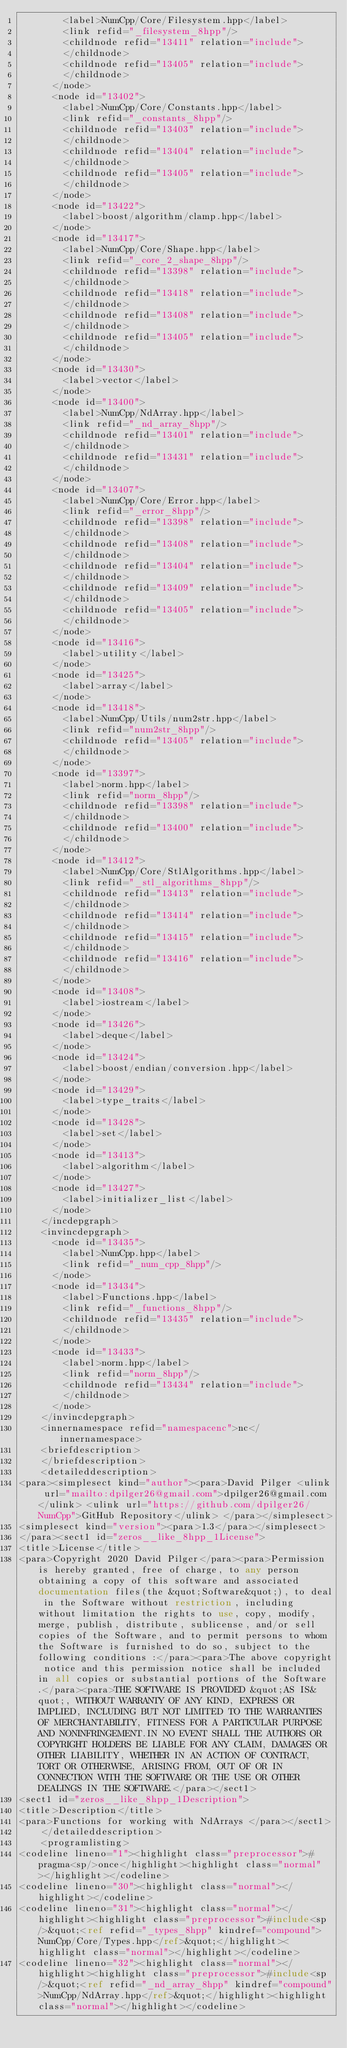<code> <loc_0><loc_0><loc_500><loc_500><_XML_>        <label>NumCpp/Core/Filesystem.hpp</label>
        <link refid="_filesystem_8hpp"/>
        <childnode refid="13411" relation="include">
        </childnode>
        <childnode refid="13405" relation="include">
        </childnode>
      </node>
      <node id="13402">
        <label>NumCpp/Core/Constants.hpp</label>
        <link refid="_constants_8hpp"/>
        <childnode refid="13403" relation="include">
        </childnode>
        <childnode refid="13404" relation="include">
        </childnode>
        <childnode refid="13405" relation="include">
        </childnode>
      </node>
      <node id="13422">
        <label>boost/algorithm/clamp.hpp</label>
      </node>
      <node id="13417">
        <label>NumCpp/Core/Shape.hpp</label>
        <link refid="_core_2_shape_8hpp"/>
        <childnode refid="13398" relation="include">
        </childnode>
        <childnode refid="13418" relation="include">
        </childnode>
        <childnode refid="13408" relation="include">
        </childnode>
        <childnode refid="13405" relation="include">
        </childnode>
      </node>
      <node id="13430">
        <label>vector</label>
      </node>
      <node id="13400">
        <label>NumCpp/NdArray.hpp</label>
        <link refid="_nd_array_8hpp"/>
        <childnode refid="13401" relation="include">
        </childnode>
        <childnode refid="13431" relation="include">
        </childnode>
      </node>
      <node id="13407">
        <label>NumCpp/Core/Error.hpp</label>
        <link refid="_error_8hpp"/>
        <childnode refid="13398" relation="include">
        </childnode>
        <childnode refid="13408" relation="include">
        </childnode>
        <childnode refid="13404" relation="include">
        </childnode>
        <childnode refid="13409" relation="include">
        </childnode>
        <childnode refid="13405" relation="include">
        </childnode>
      </node>
      <node id="13416">
        <label>utility</label>
      </node>
      <node id="13425">
        <label>array</label>
      </node>
      <node id="13418">
        <label>NumCpp/Utils/num2str.hpp</label>
        <link refid="num2str_8hpp"/>
        <childnode refid="13405" relation="include">
        </childnode>
      </node>
      <node id="13397">
        <label>norm.hpp</label>
        <link refid="norm_8hpp"/>
        <childnode refid="13398" relation="include">
        </childnode>
        <childnode refid="13400" relation="include">
        </childnode>
      </node>
      <node id="13412">
        <label>NumCpp/Core/StlAlgorithms.hpp</label>
        <link refid="_stl_algorithms_8hpp"/>
        <childnode refid="13413" relation="include">
        </childnode>
        <childnode refid="13414" relation="include">
        </childnode>
        <childnode refid="13415" relation="include">
        </childnode>
        <childnode refid="13416" relation="include">
        </childnode>
      </node>
      <node id="13408">
        <label>iostream</label>
      </node>
      <node id="13426">
        <label>deque</label>
      </node>
      <node id="13424">
        <label>boost/endian/conversion.hpp</label>
      </node>
      <node id="13429">
        <label>type_traits</label>
      </node>
      <node id="13428">
        <label>set</label>
      </node>
      <node id="13413">
        <label>algorithm</label>
      </node>
      <node id="13427">
        <label>initializer_list</label>
      </node>
    </incdepgraph>
    <invincdepgraph>
      <node id="13435">
        <label>NumCpp.hpp</label>
        <link refid="_num_cpp_8hpp"/>
      </node>
      <node id="13434">
        <label>Functions.hpp</label>
        <link refid="_functions_8hpp"/>
        <childnode refid="13435" relation="include">
        </childnode>
      </node>
      <node id="13433">
        <label>norm.hpp</label>
        <link refid="norm_8hpp"/>
        <childnode refid="13434" relation="include">
        </childnode>
      </node>
    </invincdepgraph>
    <innernamespace refid="namespacenc">nc</innernamespace>
    <briefdescription>
    </briefdescription>
    <detaileddescription>
<para><simplesect kind="author"><para>David Pilger <ulink url="mailto:dpilger26@gmail.com">dpilger26@gmail.com</ulink> <ulink url="https://github.com/dpilger26/NumCpp">GitHub Repository</ulink> </para></simplesect>
<simplesect kind="version"><para>1.3</para></simplesect>
</para><sect1 id="zeros__like_8hpp_1License">
<title>License</title>
<para>Copyright 2020 David Pilger</para><para>Permission is hereby granted, free of charge, to any person obtaining a copy of this software and associated documentation files(the &quot;Software&quot;), to deal in the Software without restriction, including without limitation the rights to use, copy, modify, merge, publish, distribute, sublicense, and/or sell copies of the Software, and to permit persons to whom the Software is furnished to do so, subject to the following conditions :</para><para>The above copyright notice and this permission notice shall be included in all copies or substantial portions of the Software.</para><para>THE SOFTWARE IS PROVIDED &quot;AS IS&quot;, WITHOUT WARRANTY OF ANY KIND, EXPRESS OR IMPLIED, INCLUDING BUT NOT LIMITED TO THE WARRANTIES OF MERCHANTABILITY, FITNESS FOR A PARTICULAR PURPOSE AND NONINFRINGEMENT.IN NO EVENT SHALL THE AUTHORS OR COPYRIGHT HOLDERS BE LIABLE FOR ANY CLAIM, DAMAGES OR OTHER LIABILITY, WHETHER IN AN ACTION OF CONTRACT, TORT OR OTHERWISE, ARISING FROM, OUT OF OR IN CONNECTION WITH THE SOFTWARE OR THE USE OR OTHER DEALINGS IN THE SOFTWARE.</para></sect1>
<sect1 id="zeros__like_8hpp_1Description">
<title>Description</title>
<para>Functions for working with NdArrays </para></sect1>
    </detaileddescription>
    <programlisting>
<codeline lineno="1"><highlight class="preprocessor">#pragma<sp/>once</highlight><highlight class="normal"></highlight></codeline>
<codeline lineno="30"><highlight class="normal"></highlight></codeline>
<codeline lineno="31"><highlight class="normal"></highlight><highlight class="preprocessor">#include<sp/>&quot;<ref refid="_types_8hpp" kindref="compound">NumCpp/Core/Types.hpp</ref>&quot;</highlight><highlight class="normal"></highlight></codeline>
<codeline lineno="32"><highlight class="normal"></highlight><highlight class="preprocessor">#include<sp/>&quot;<ref refid="_nd_array_8hpp" kindref="compound">NumCpp/NdArray.hpp</ref>&quot;</highlight><highlight class="normal"></highlight></codeline></code> 